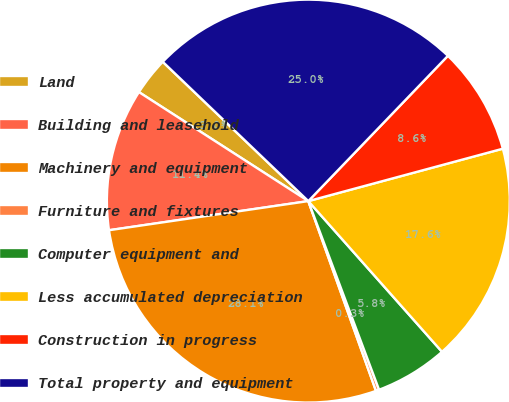Convert chart to OTSL. <chart><loc_0><loc_0><loc_500><loc_500><pie_chart><fcel>Land<fcel>Building and leasehold<fcel>Machinery and equipment<fcel>Furniture and fixtures<fcel>Computer equipment and<fcel>Less accumulated depreciation<fcel>Construction in progress<fcel>Total property and equipment<nl><fcel>3.05%<fcel>11.41%<fcel>28.14%<fcel>0.26%<fcel>5.84%<fcel>17.64%<fcel>8.63%<fcel>25.03%<nl></chart> 